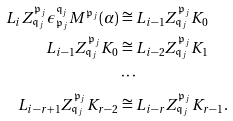<formula> <loc_0><loc_0><loc_500><loc_500>L _ { i } Z _ { \mathfrak { q } _ { j } } ^ { \mathfrak { p } _ { j } } \epsilon _ { \mathfrak { p } _ { j } } ^ { \mathfrak { q } _ { j } } M ^ { \mathfrak { p } _ { j } } ( \alpha ) & \cong L _ { i - 1 } Z _ { \mathfrak { q } _ { j } } ^ { \mathfrak { p } _ { j } } K _ { 0 } \\ L _ { i - 1 } Z _ { \mathfrak { q } _ { j } } ^ { \mathfrak { p } _ { j } } K _ { 0 } & \cong L _ { i - 2 } Z _ { \mathfrak { q } _ { j } } ^ { \mathfrak { p } _ { j } } K _ { 1 } \\ & \cdots \\ L _ { i - r + 1 } Z _ { \mathfrak { q } _ { j } } ^ { \mathfrak { p } _ { j } } K _ { r - 2 } & \cong L _ { i - r } Z _ { \mathfrak { q } _ { j } } ^ { \mathfrak { p } _ { j } } K _ { r - 1 } .</formula> 